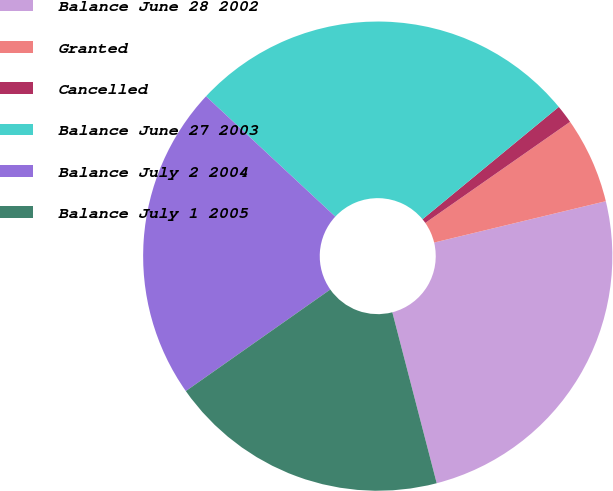Convert chart. <chart><loc_0><loc_0><loc_500><loc_500><pie_chart><fcel>Balance June 28 2002<fcel>Granted<fcel>Cancelled<fcel>Balance June 27 2003<fcel>Balance July 2 2004<fcel>Balance July 1 2005<nl><fcel>24.72%<fcel>5.94%<fcel>1.27%<fcel>27.1%<fcel>21.68%<fcel>19.29%<nl></chart> 